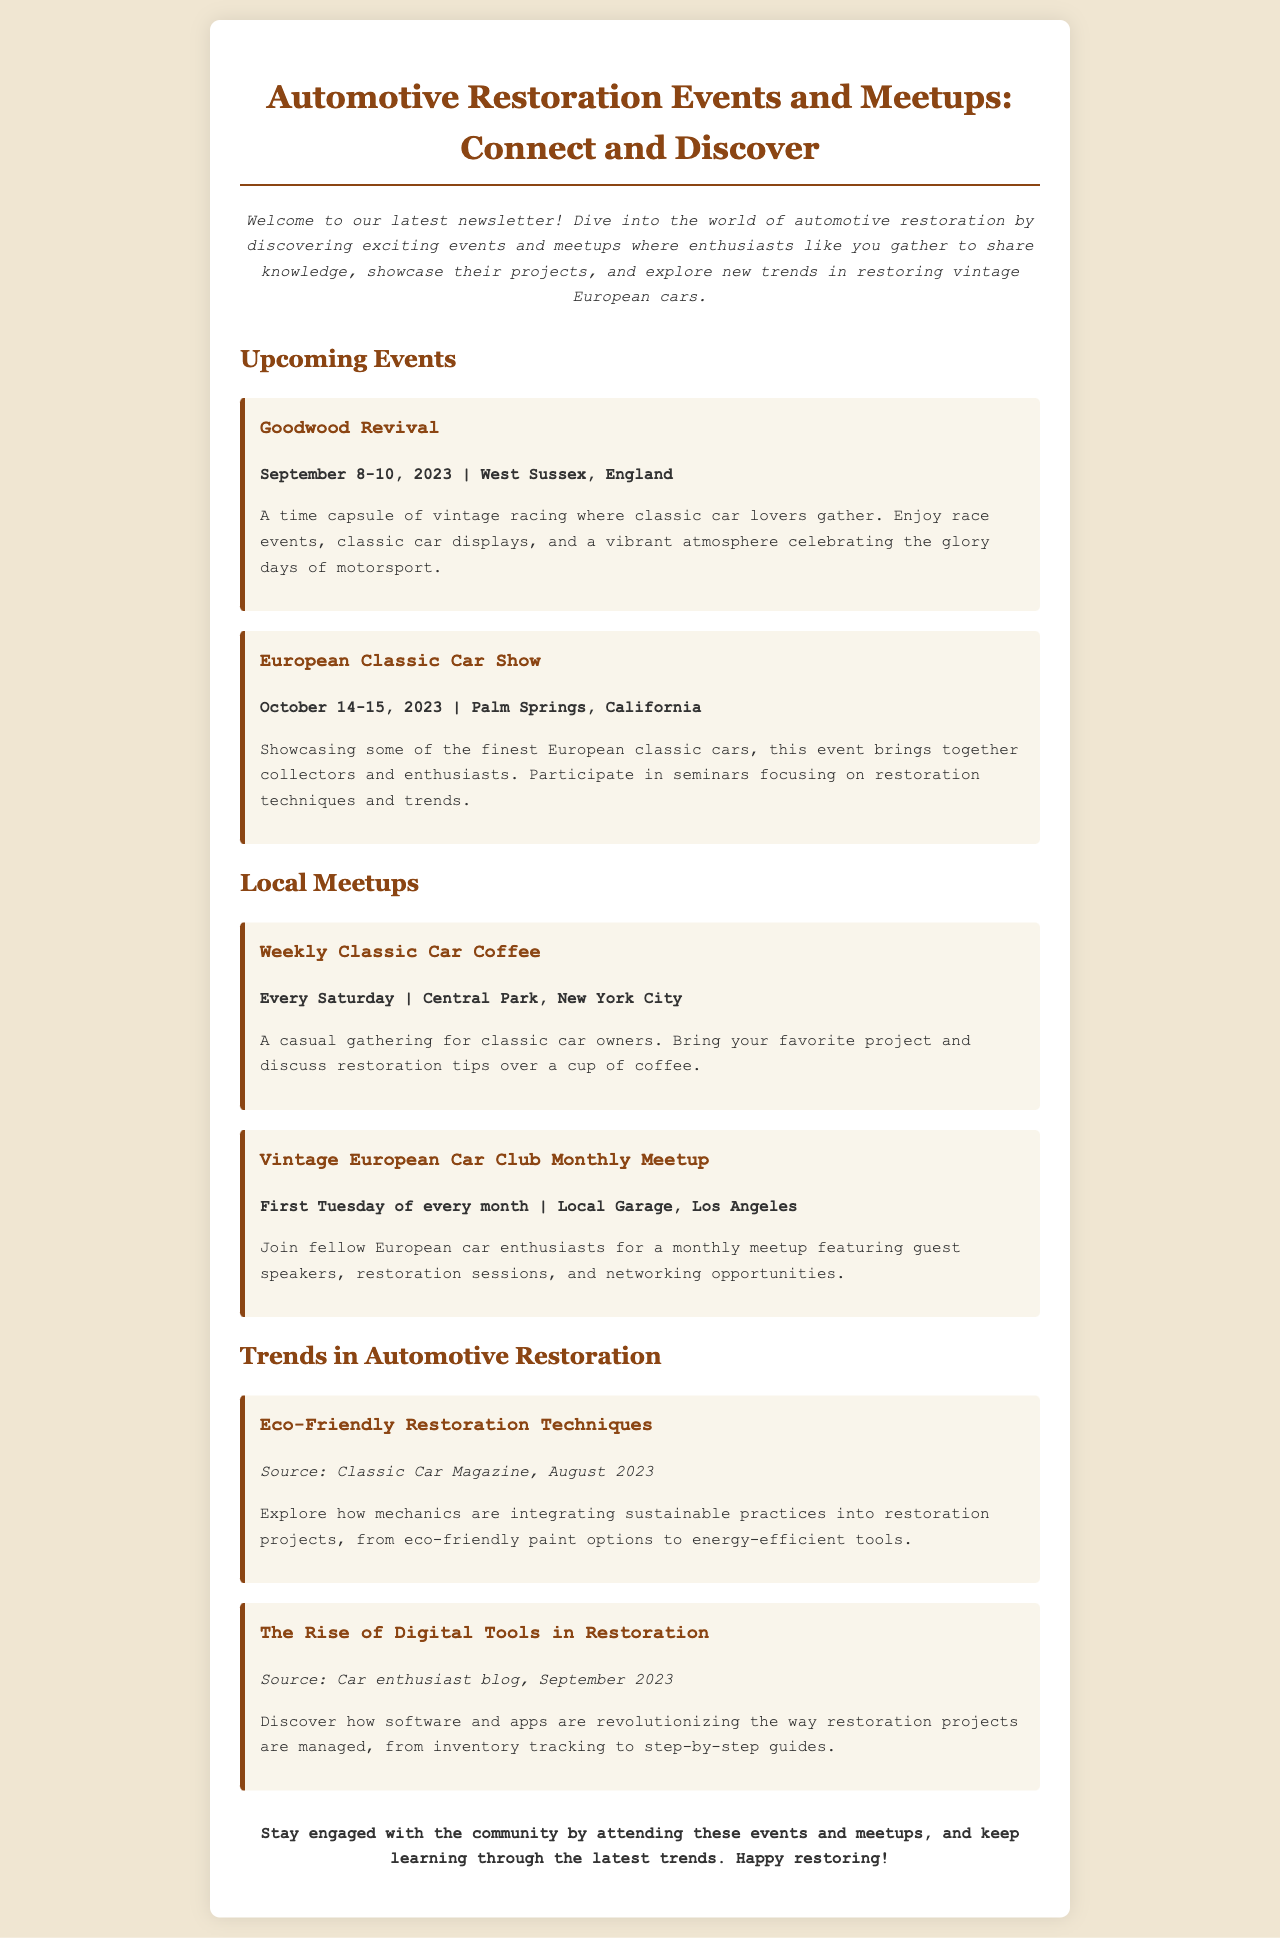What is the title of the newsletter? The title introduces the main theme and content of the newsletter, which focuses on automotive restoration events and meetups.
Answer: Automotive Restoration Events and Meetups: Connect and Discover When is the European Classic Car Show happening? The date of the event is provided in the event details, specifying when it will take place.
Answer: October 14-15, 2023 Where is the Goodwood Revival held? The location of the event is mentioned alongside its date, indicating where participants can attend.
Answer: West Sussex, England What is a feature of the Vintage European Car Club Monthly Meetup? The meetup includes specific activities that aim to foster community and learning among members.
Answer: Guest speakers What sustainable practice is mentioned in the trends section? The document lists specific techniques that mechanics are adopting to enhance eco-friendliness in their restoration work.
Answer: Eco-friendly paint options What day does the Weekly Classic Car Coffee occur? The document specifies the weekly schedule for this casual gathering, identifying when classic car owners can meet.
Answer: Every Saturday How often does the Vintage European Car Club hold meetings? The frequency of this particular meetup is outlined in the document to give readers a sense of participation opportunities.
Answer: Monthly Which magazine is cited for eco-friendly restoration techniques? An authoritative source is provided for the specific information on sustainable practices in automotive restoration.
Answer: Classic Car Magazine What type of tools is highlighted in the trend for restoration? The document discusses innovative tools that are changing the restoration landscape, emphasizing technological advancements.
Answer: Digital tools 